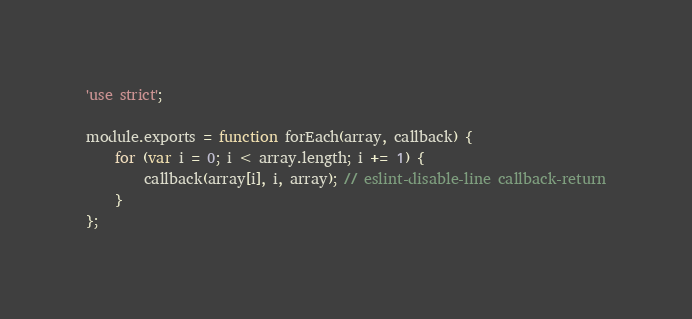Convert code to text. <code><loc_0><loc_0><loc_500><loc_500><_JavaScript_>'use strict';

module.exports = function forEach(array, callback) {
	for (var i = 0; i < array.length; i += 1) {
		callback(array[i], i, array); // eslint-disable-line callback-return
	}
};
</code> 